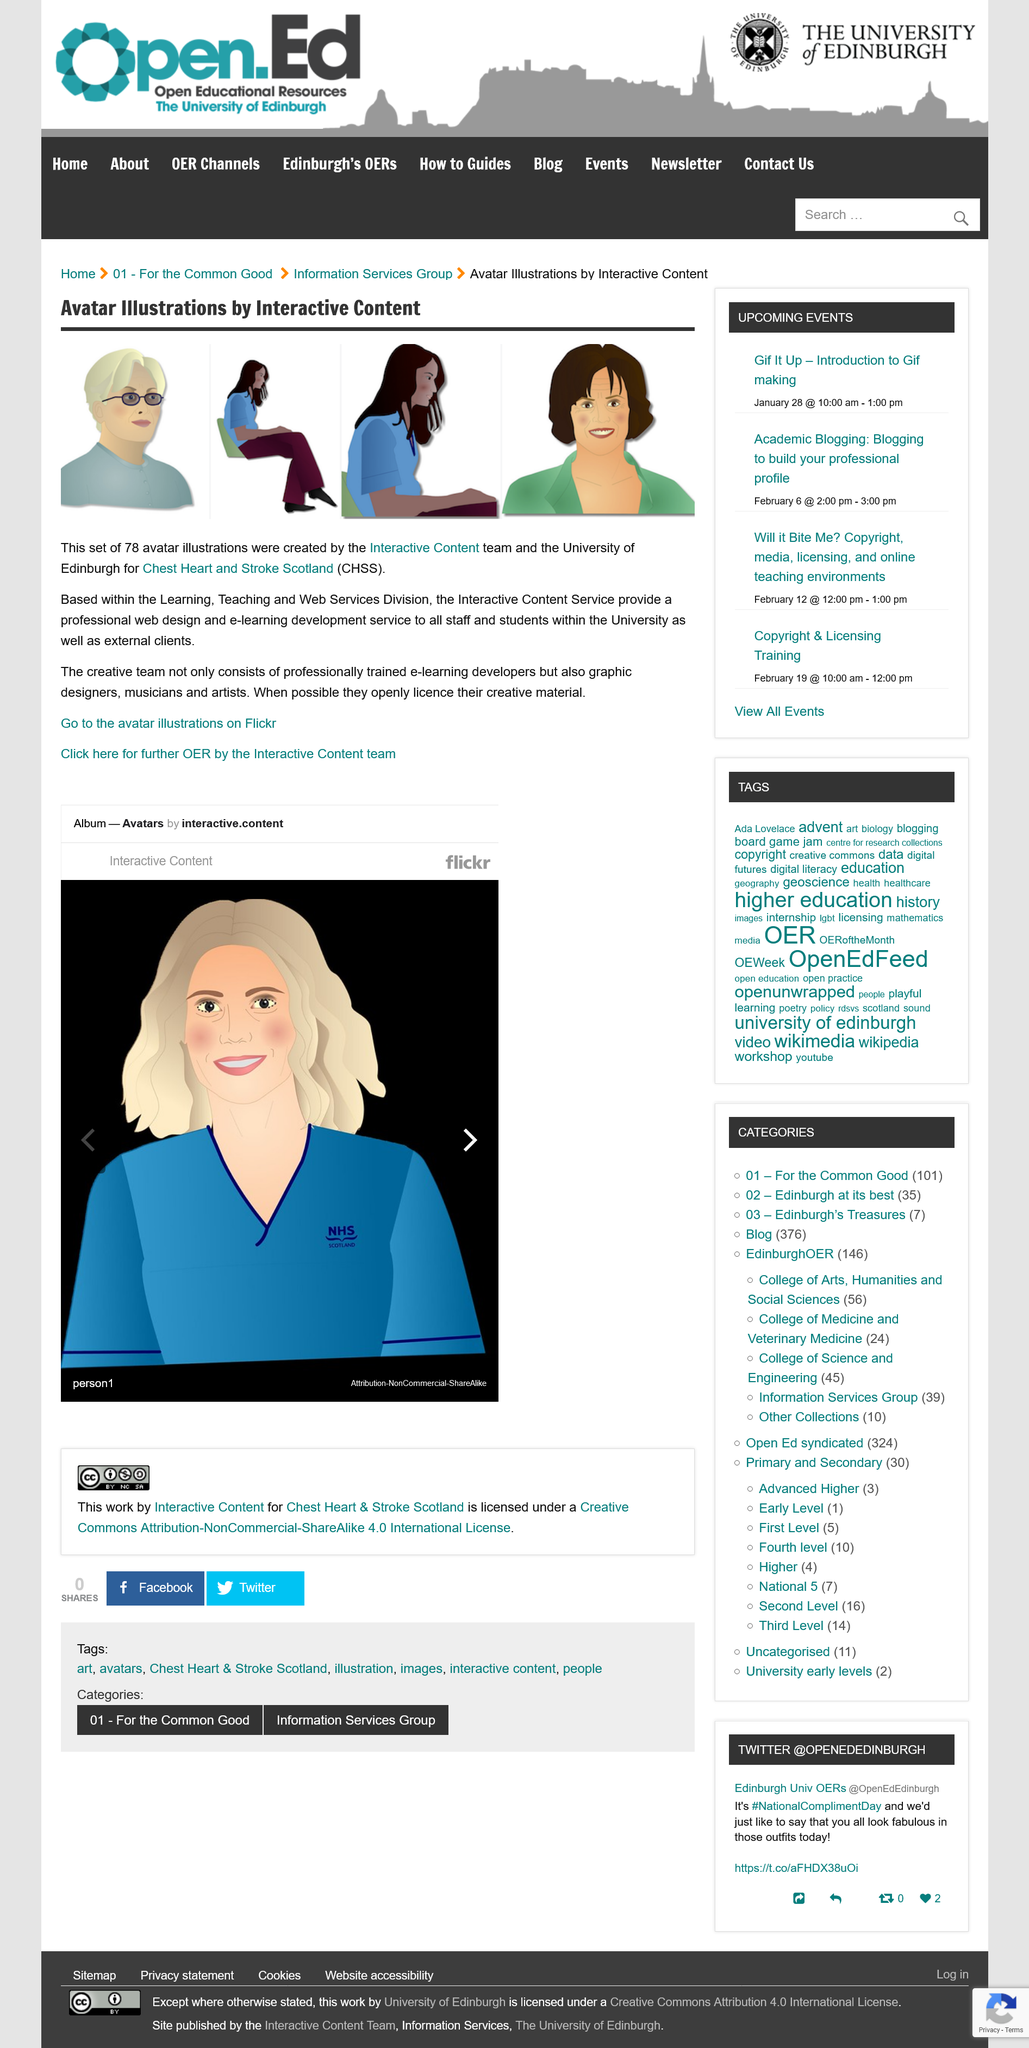Indicate a few pertinent items in this graphic. It is possible to locate avatar illustrations through the use of image services such as Flickr. The team is from Edinburgh University and specializes in providing professional web design and e-learning development services. There are 78 avatar illustrations in total. 